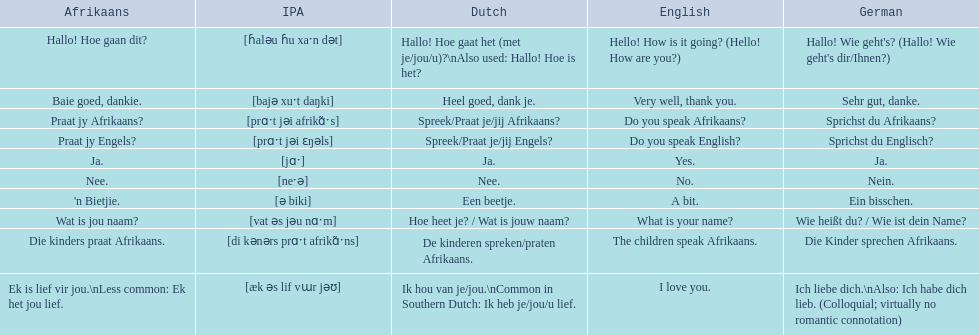What are the mentioned afrikaans expressions? Hallo! Hoe gaan dit?, Baie goed, dankie., Praat jy Afrikaans?, Praat jy Engels?, Ja., Nee., 'n Bietjie., Wat is jou naam?, Die kinders praat Afrikaans., Ek is lief vir jou.\nLess common: Ek het jou lief. Which one refers to "die kinders praat afrikaans"? Die kinders praat Afrikaans. What is the german equivalent of it? Die Kinder sprechen Afrikaans. 